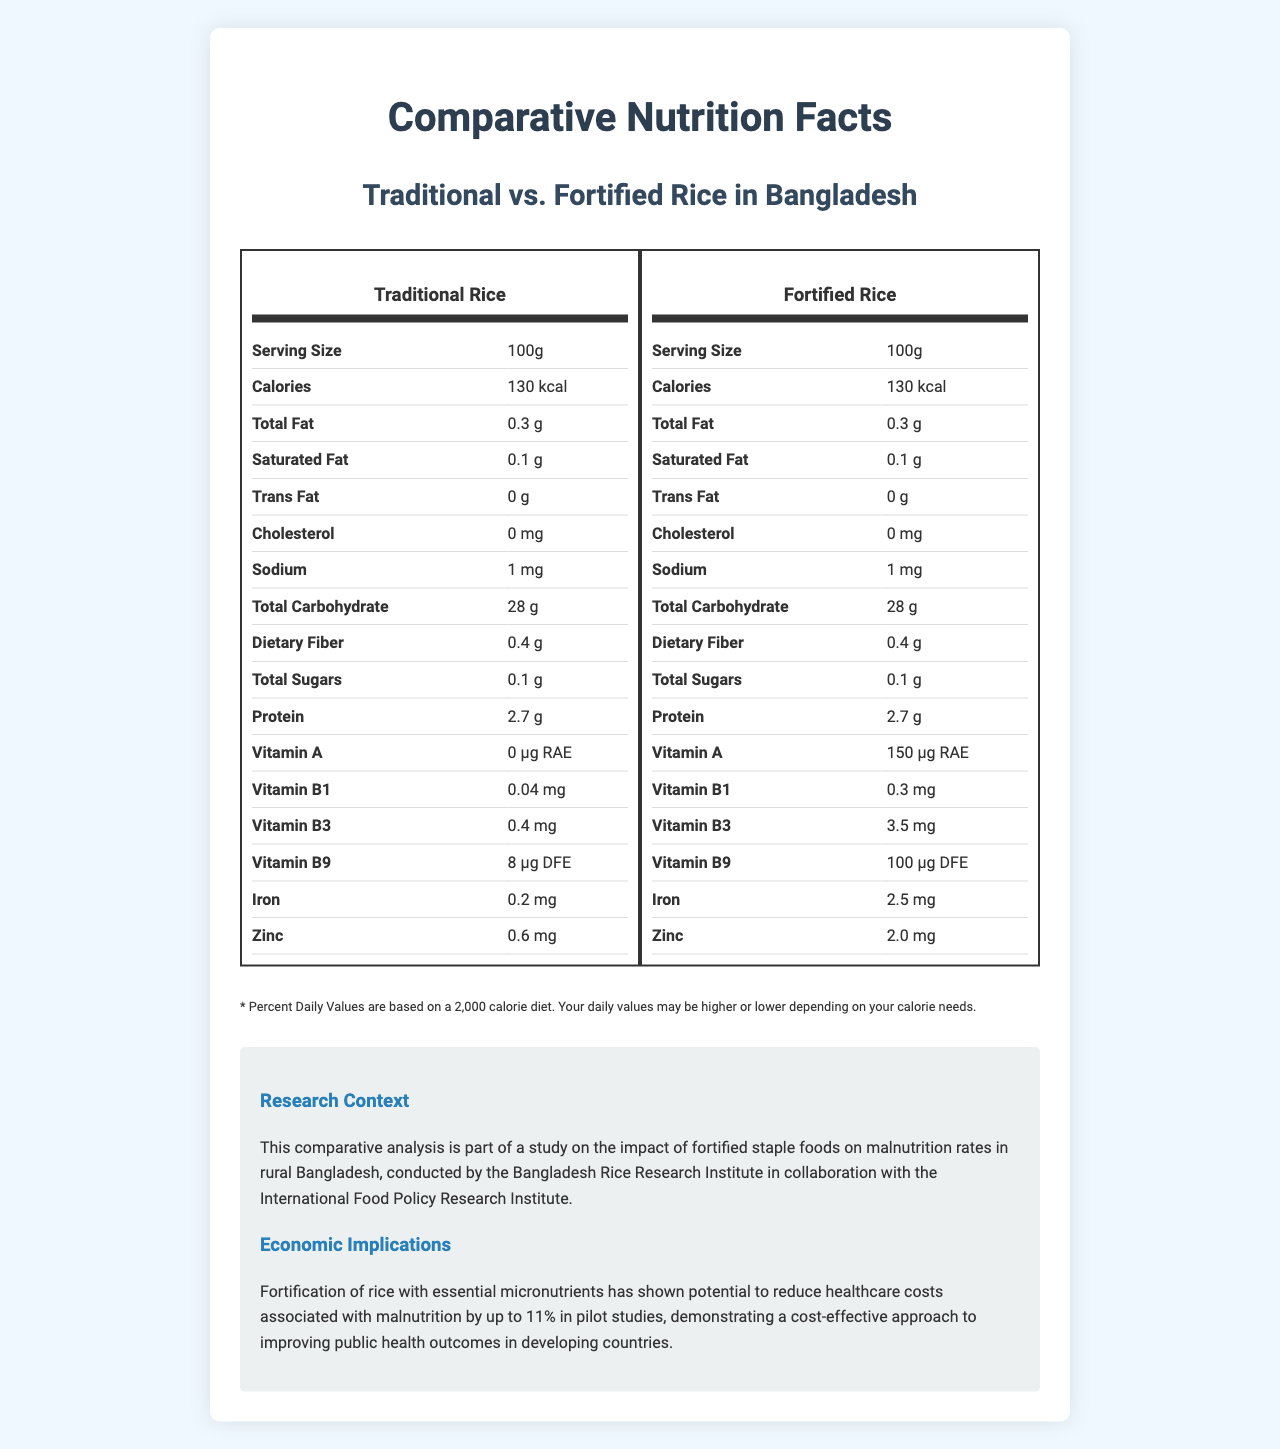what is the serving size for both types of rice? The serving size is listed as "100g" for both Traditional Rice and Fortified Rice.
Answer: 100g how much vitamin A is in traditional rice? The nutrition facts for traditional rice show "Vitamin A: 0 μg RAE".
Answer: 0 μg RAE which type of rice has a higher amount of iron per serving? Traditional Rice has 0.2 mg of iron, while Fortified Rice has 2.5 mg of iron per serving, making Fortified Rice the higher source of iron.
Answer: Fortified Rice what is the difference in vitamin B9 between traditional and fortified rice? Traditional Rice contains 8 μg DFE of vitamin B9, whereas Fortified Rice contains 100 μg DFE. The difference is 100 μg DFE - 8 μg DFE = 92 μg DFE.
Answer: 92 μg DFE how many calories do both types of rice contain per serving? Both Traditional and Fortified Rice have 130 kcal per 100g serving.
Answer: 130 kcal does fortified rice contain any cholesterol? Both Traditional and Fortified Rice have 0 mg of cholesterol.
Answer: No is there a difference in the dietary fiber content between traditional and fortified rice? Both Traditional and Fortified Rice have 0.4 g of dietary fiber per serving.
Answer: No what is the main difference in the vitamin and mineral content between traditional and fortified rice? Fortified Rice contains significantly higher levels of Vitamin A, Vitamin B1, Vitamin B3, Vitamin B9, Iron, and Zinc compared to Traditional Rice.
Answer: Fortified Rice has higher amounts of vitamins and minerals. what is the potential economic benefit of using fortified rice mentioned in the document? A. Increased crop yields B. Reduced healthcare costs associated with malnutrition C. Lower import taxes D. Enhanced flavor of rice The document states that "Fortification of rice with essential micronutrients has shown potential to reduce healthcare costs associated with malnutrition by up to 11%".
Answer: B which vitamin shows the greatest increase in content when comparing fortified rice to traditional rice? A. Vitamin A B. Vitamin B1 C. Vitamin B3 D. Vitamin B9 Vitamin A shows the greatest increase—from 0 μg RAE in Traditional Rice to 150 μg RAE in Fortified Rice.
Answer: A can we determine the price of fortified rice from the document? The document does not provide any pricing details for either Traditional or Fortified Rice.
Answer: Not enough information what is the purpose of this comparative analysis? The "Research Context" section explains that this analysis is part of a study on the impact of fortifying staple foods, such as rice, on malnutrition rates.
Answer: To study the impact of fortified staple foods on malnutrition rates in rural Bangladesh. what does the footnote about daily values indicate? The footnote specifies that the Percent Daily Values are calculated based on a standard 2,000 calorie diet and that individual daily values may vary.
Answer: Percent Daily Values are based on a 2,000 calorie diet and may vary based on individual calorie needs. summarize the entire document The document includes detailed nutrition facts for both types of rice, a footnote about daily values, and an explanation of the research context and economic implications, highlighting the benefits of rice fortification.
Answer: The document presents a comparative analysis of the nutritional differences between traditional and fortified rice in Bangladesh, emphasizing the higher vitamin and mineral content of the fortified rice. It discusses the potential health benefits and economic implications of using fortified rice to reduce malnutrition and healthcare costs. 